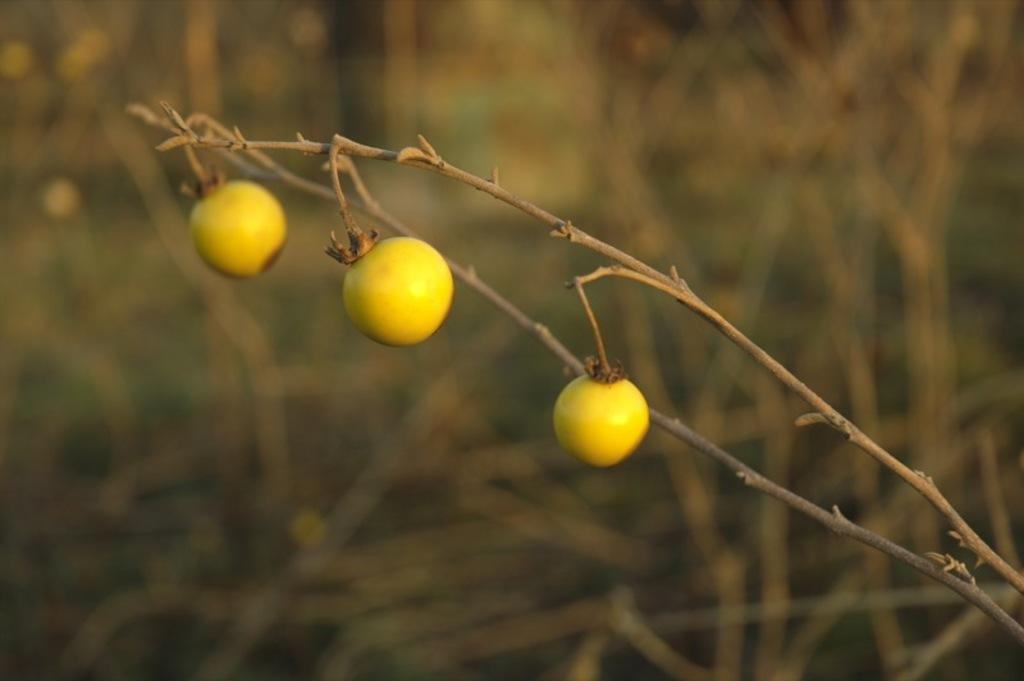What type of food is visible on the stem in the image? There are fruits on a stem in the image. Can you describe the background of the image? The background of the image is blurry. What type of toe can be seen smiling in the image? There are no toes or smiles present in the image; it features fruits on a stem with a blurry background. 